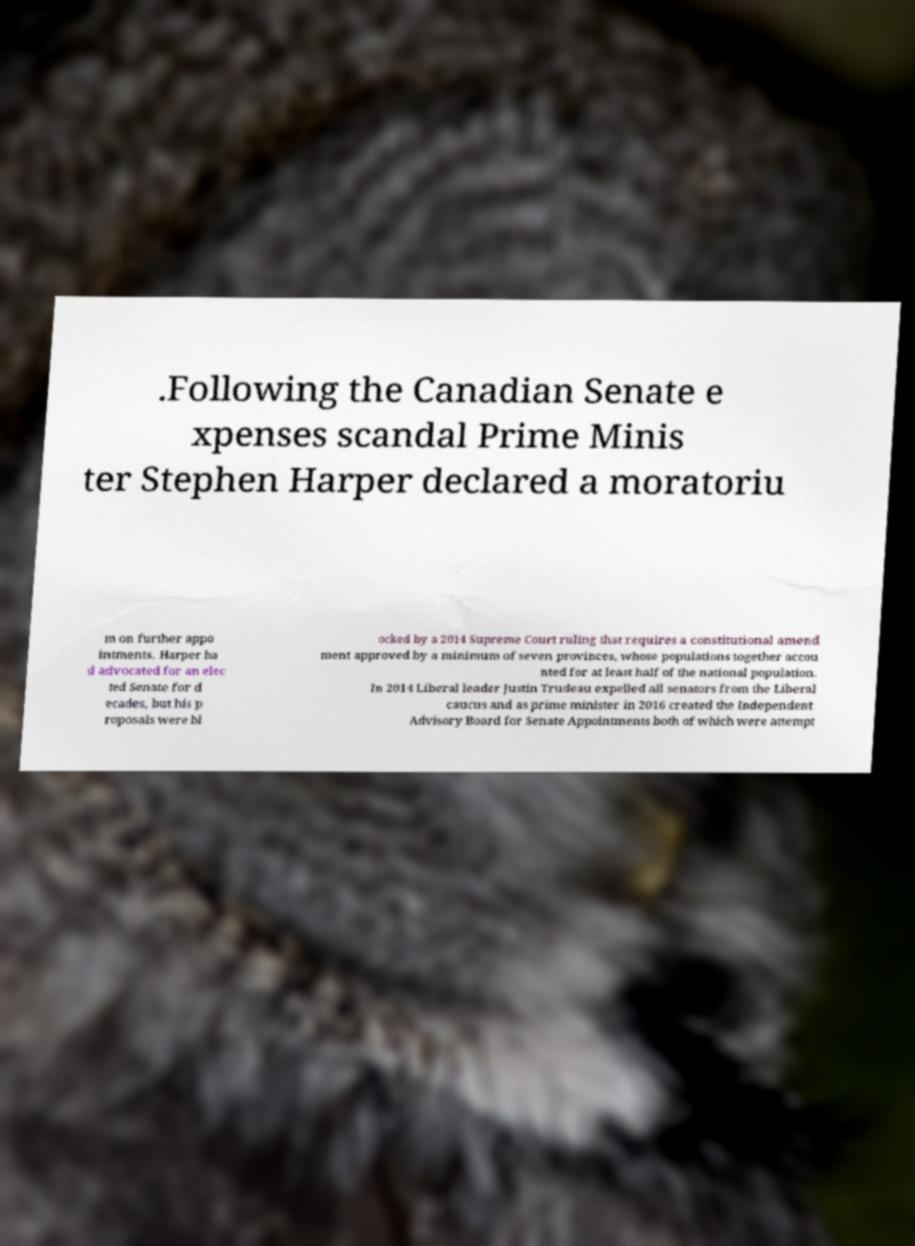What messages or text are displayed in this image? I need them in a readable, typed format. .Following the Canadian Senate e xpenses scandal Prime Minis ter Stephen Harper declared a moratoriu m on further appo intments. Harper ha d advocated for an elec ted Senate for d ecades, but his p roposals were bl ocked by a 2014 Supreme Court ruling that requires a constitutional amend ment approved by a minimum of seven provinces, whose populations together accou nted for at least half of the national population. In 2014 Liberal leader Justin Trudeau expelled all senators from the Liberal caucus and as prime minister in 2016 created the Independent Advisory Board for Senate Appointments both of which were attempt 